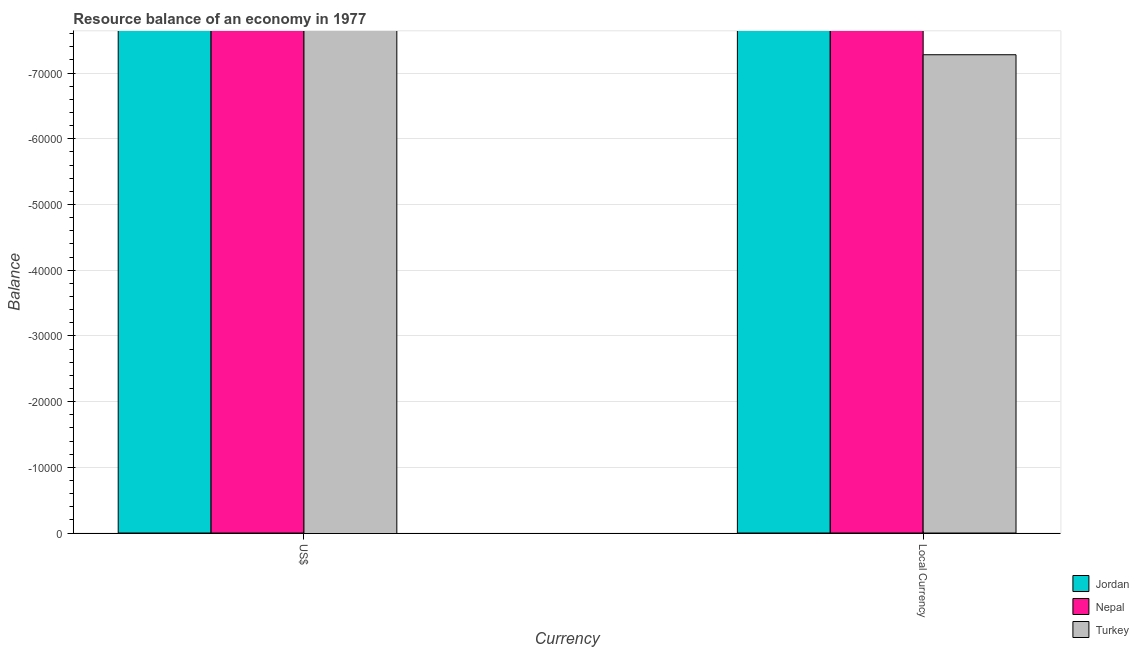How many bars are there on the 2nd tick from the left?
Provide a short and direct response. 0. How many bars are there on the 2nd tick from the right?
Keep it short and to the point. 0. What is the label of the 2nd group of bars from the left?
Your answer should be compact. Local Currency. Across all countries, what is the minimum resource balance in us$?
Give a very brief answer. 0. In how many countries, is the resource balance in constant us$ greater than -56000 units?
Offer a terse response. 0. What is the difference between two consecutive major ticks on the Y-axis?
Provide a short and direct response. 10000. Are the values on the major ticks of Y-axis written in scientific E-notation?
Make the answer very short. No. Does the graph contain any zero values?
Provide a succinct answer. Yes. How many legend labels are there?
Offer a terse response. 3. How are the legend labels stacked?
Offer a very short reply. Vertical. What is the title of the graph?
Your answer should be compact. Resource balance of an economy in 1977. What is the label or title of the X-axis?
Your response must be concise. Currency. What is the label or title of the Y-axis?
Make the answer very short. Balance. What is the Balance of Nepal in US$?
Ensure brevity in your answer.  0. What is the Balance in Turkey in US$?
Offer a very short reply. 0. What is the Balance of Jordan in Local Currency?
Ensure brevity in your answer.  0. What is the Balance in Nepal in Local Currency?
Make the answer very short. 0. What is the Balance of Turkey in Local Currency?
Your answer should be compact. 0. What is the total Balance of Jordan in the graph?
Provide a succinct answer. 0. What is the total Balance in Turkey in the graph?
Your response must be concise. 0. What is the average Balance of Nepal per Currency?
Provide a short and direct response. 0. What is the average Balance of Turkey per Currency?
Give a very brief answer. 0. 